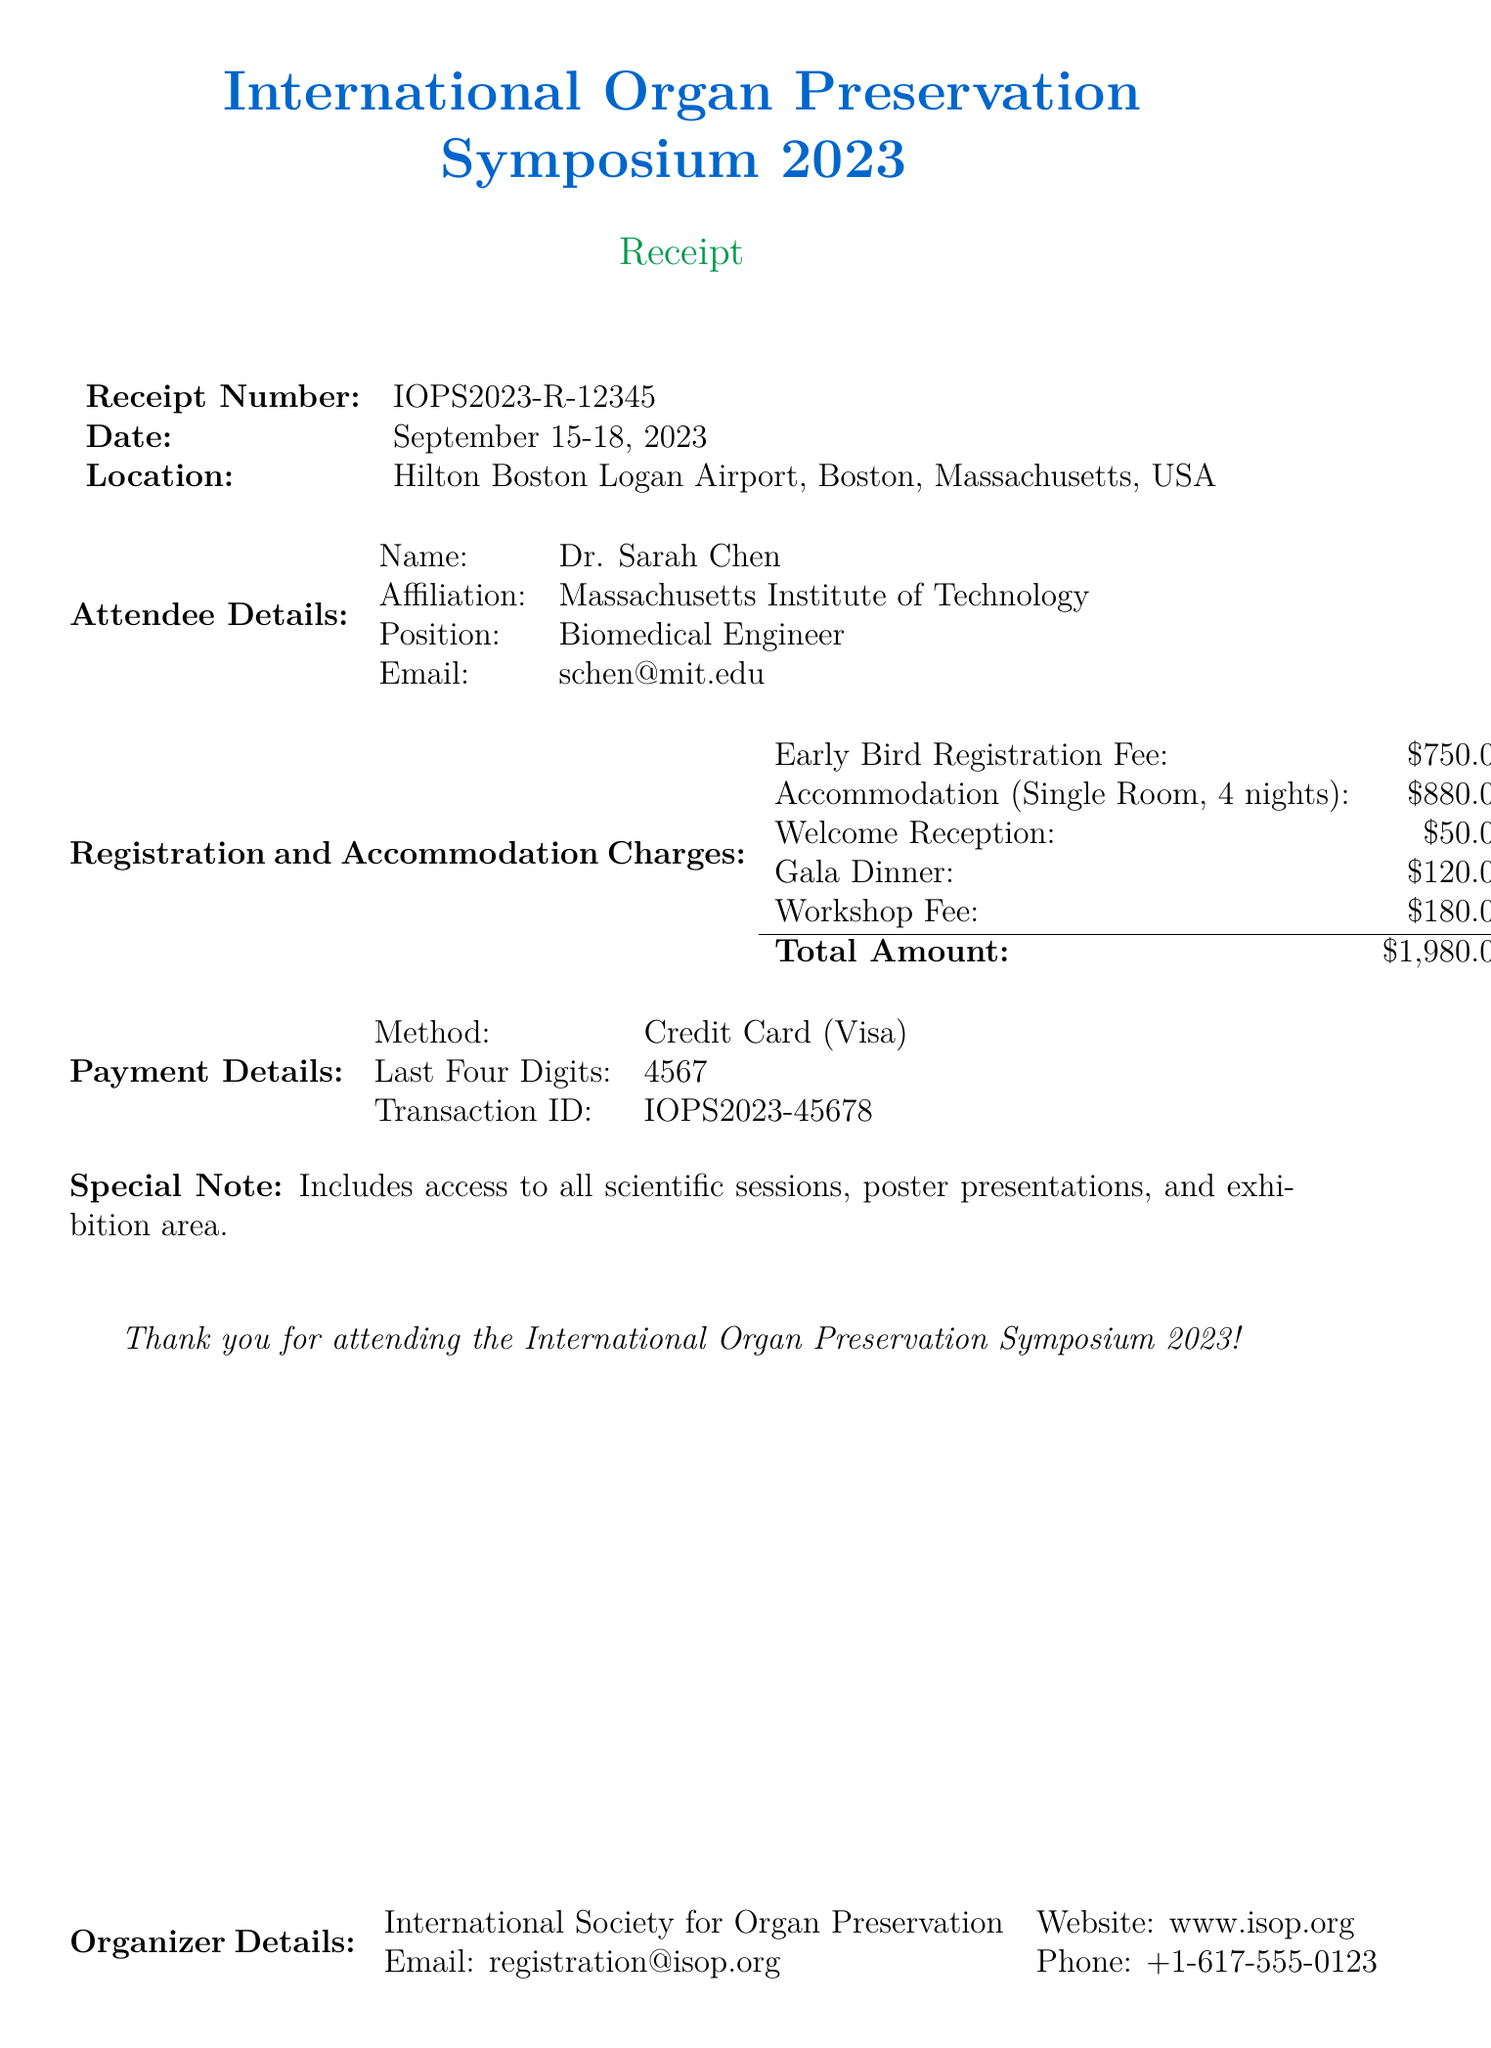What is the conference name? The conference name is the title presented at the top of the document.
Answer: International Organ Preservation Symposium 2023 What are the dates of the conference? The dates located under the receipt number indicate when the conference is taking place.
Answer: September 15-18, 2023 What is the total amount charged? The total amount is found in the 'Total Amount' section, summarized at the end of the charges.
Answer: $1,980.00 How many nights is the accommodation for? The number of nights is specified in the accommodation section detailing the room charges.
Answer: 4 What is the registration fee for early bird? The early bird registration fee is listed in the registration charges section.
Answer: $750.00 What is the email address of the organizer? The email of the organizer is stated in the Organizer Details section.
Answer: registration@isop.org What type of credit card was used for payment? The payment details indicate the type of credit card processed for the transaction.
Answer: Visa Which room type has the highest charge per night? The accommodation section lists different room types with their corresponding charges; the highest is identified in that section.
Answer: Suite Room What additional charge is associated with the gala dinner? The gala dinner charge is found in the additional charges section.
Answer: $120.00 